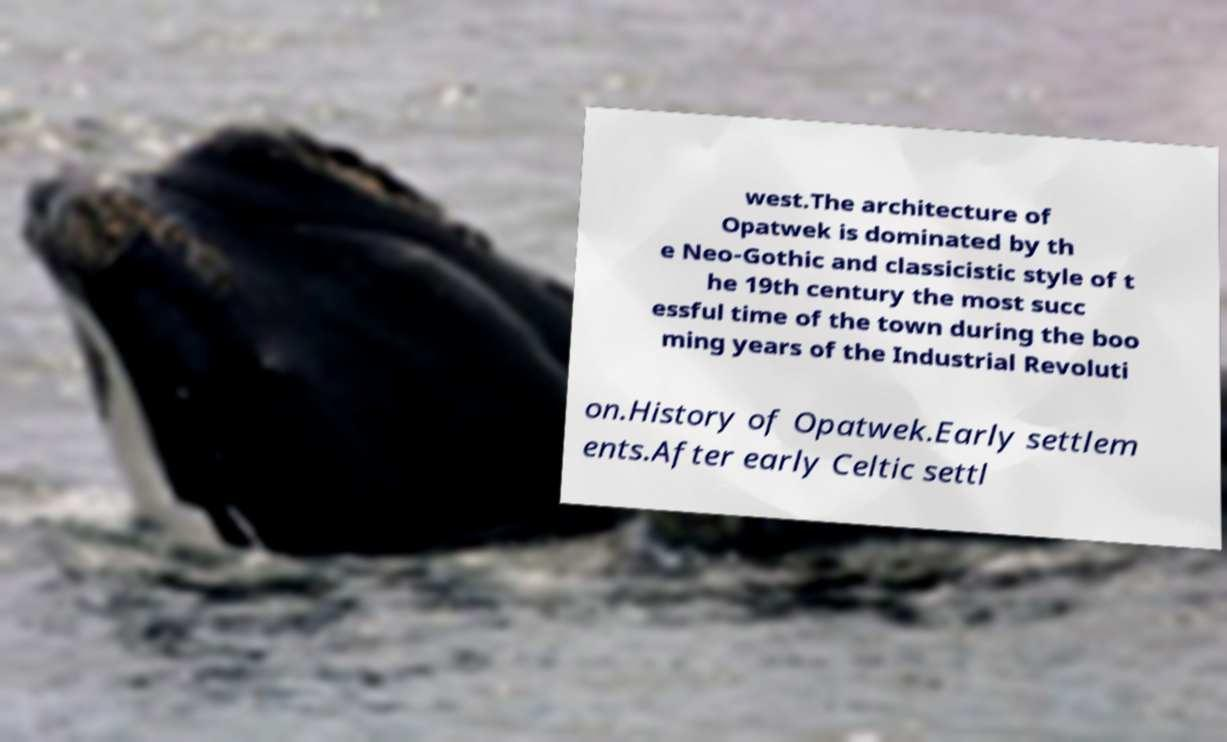Please identify and transcribe the text found in this image. west.The architecture of Opatwek is dominated by th e Neo-Gothic and classicistic style of t he 19th century the most succ essful time of the town during the boo ming years of the Industrial Revoluti on.History of Opatwek.Early settlem ents.After early Celtic settl 